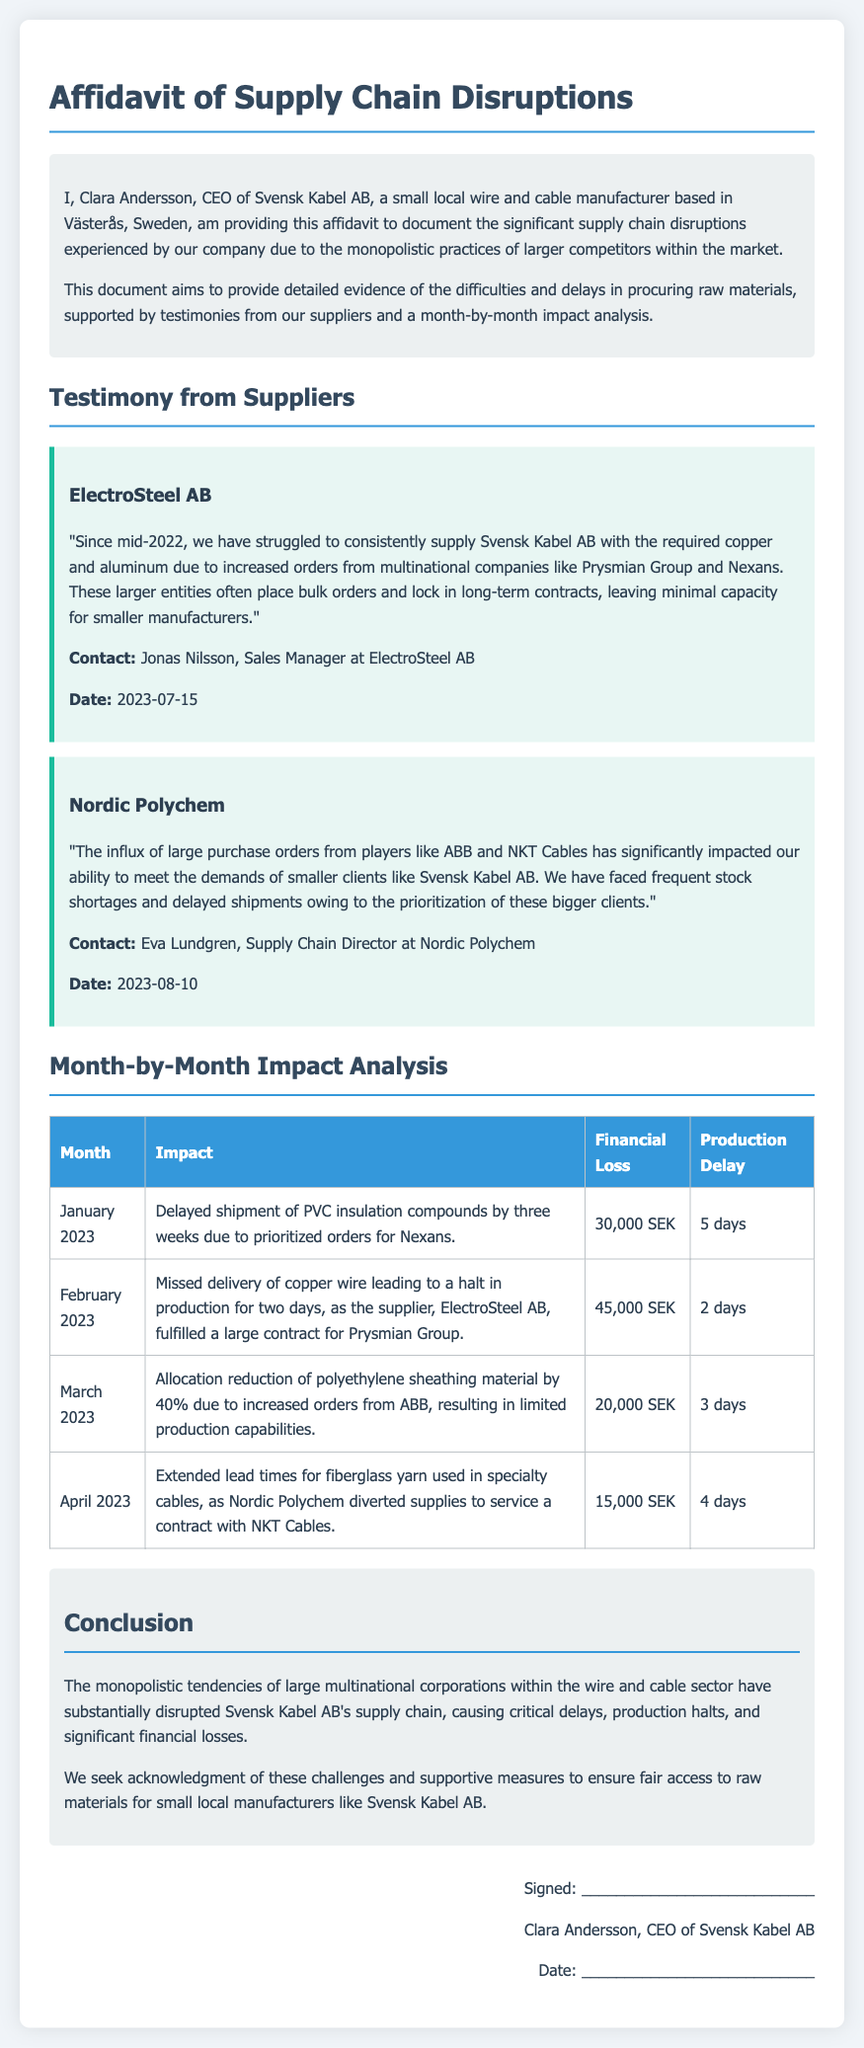What is the name of the CEO of Svensk Kabel AB? The document mentions Clara Andersson as the CEO of Svensk Kabel AB.
Answer: Clara Andersson Which supplier reported a struggle to supply copper and aluminum? The testimony from ElectroSteel AB mentions struggles with supplying materials.
Answer: ElectroSteel AB What impact did the company face in January 2023? The January entry describes a delayed shipment of PVC insulation compounds due to prioritized orders.
Answer: Delayed shipment of PVC insulation compounds How much financial loss did Svensk Kabel AB incur in February 2023? The document states the financial loss for February 2023 amounted to 45,000 SEK.
Answer: 45,000 SEK Which month did Svensk Kabel AB experience a halt in production? The document notes that production was halted in February 2023 due to missed delivery of copper wire.
Answer: February 2023 What percentage was the allocation reduction of polyethylene sheathing material in March 2023? The month of March specifies a 40% allocation reduction of the polyethylene sheathing material.
Answer: 40% Who is the Supply Chain Director at Nordic Polychem? The document identifies Eva Lundgren as the Supply Chain Director at Nordic Polychem.
Answer: Eva Lundgren What was the conclusion of the affidavit regarding the monopolistic tendencies? The conclusion states that such tendencies have substantially disrupted supply chains and caused losses.
Answer: Disrupted supply chains and caused losses 